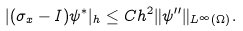Convert formula to latex. <formula><loc_0><loc_0><loc_500><loc_500>| ( \sigma _ { x } - I ) \psi ^ { \ast } | _ { h } \leq C h ^ { 2 } \| \psi ^ { \prime \prime } \| _ { L ^ { \infty } ( \Omega ) } .</formula> 